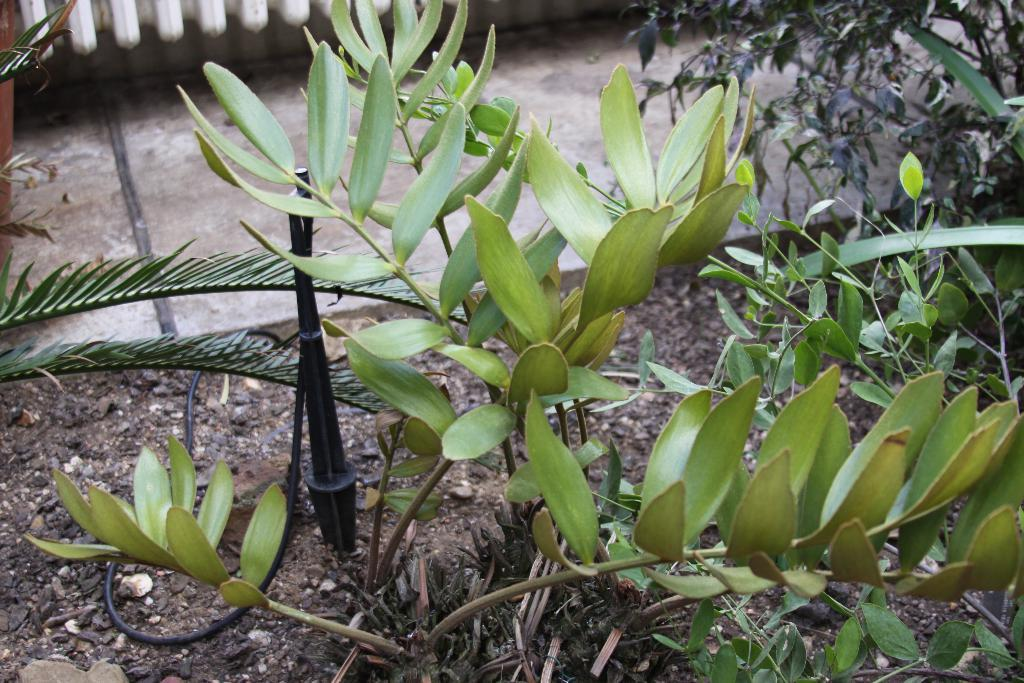What type of living organisms can be seen in the image? Plants can be seen in the image. Where are the plants located? The plants are on the soil. What type of attraction is present in the image? There is no attraction present in the image; it only features plants on the soil. What kind of stone can be seen in the image? There is no stone present in the image. 